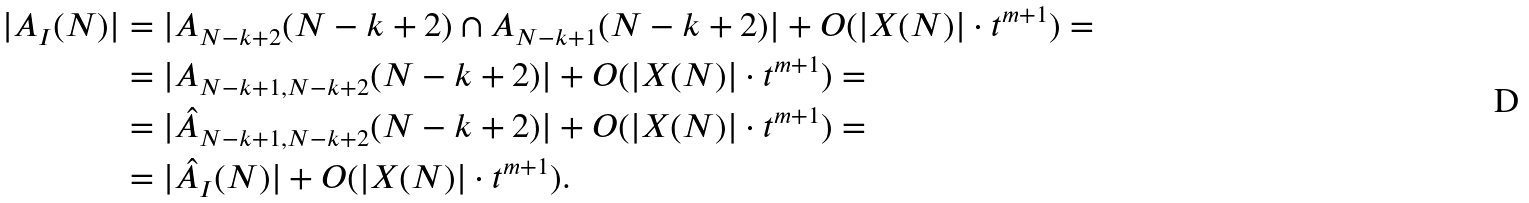Convert formula to latex. <formula><loc_0><loc_0><loc_500><loc_500>| A _ { I } ( N ) | & = | A _ { N - k + 2 } ( N - k + 2 ) \cap A _ { N - k + 1 } ( N - k + 2 ) | + O ( | X ( N ) | \cdot t ^ { m + 1 } ) = \\ & = | A _ { N - k + 1 , N - k + 2 } ( N - k + 2 ) | + O ( | X ( N ) | \cdot t ^ { m + 1 } ) = \\ & = | \hat { A } _ { N - k + 1 , N - k + 2 } ( N - k + 2 ) | + O ( | X ( N ) | \cdot t ^ { m + 1 } ) = \\ & = | \hat { A } _ { I } ( N ) | + O ( | X ( N ) | \cdot t ^ { m + 1 } ) .</formula> 